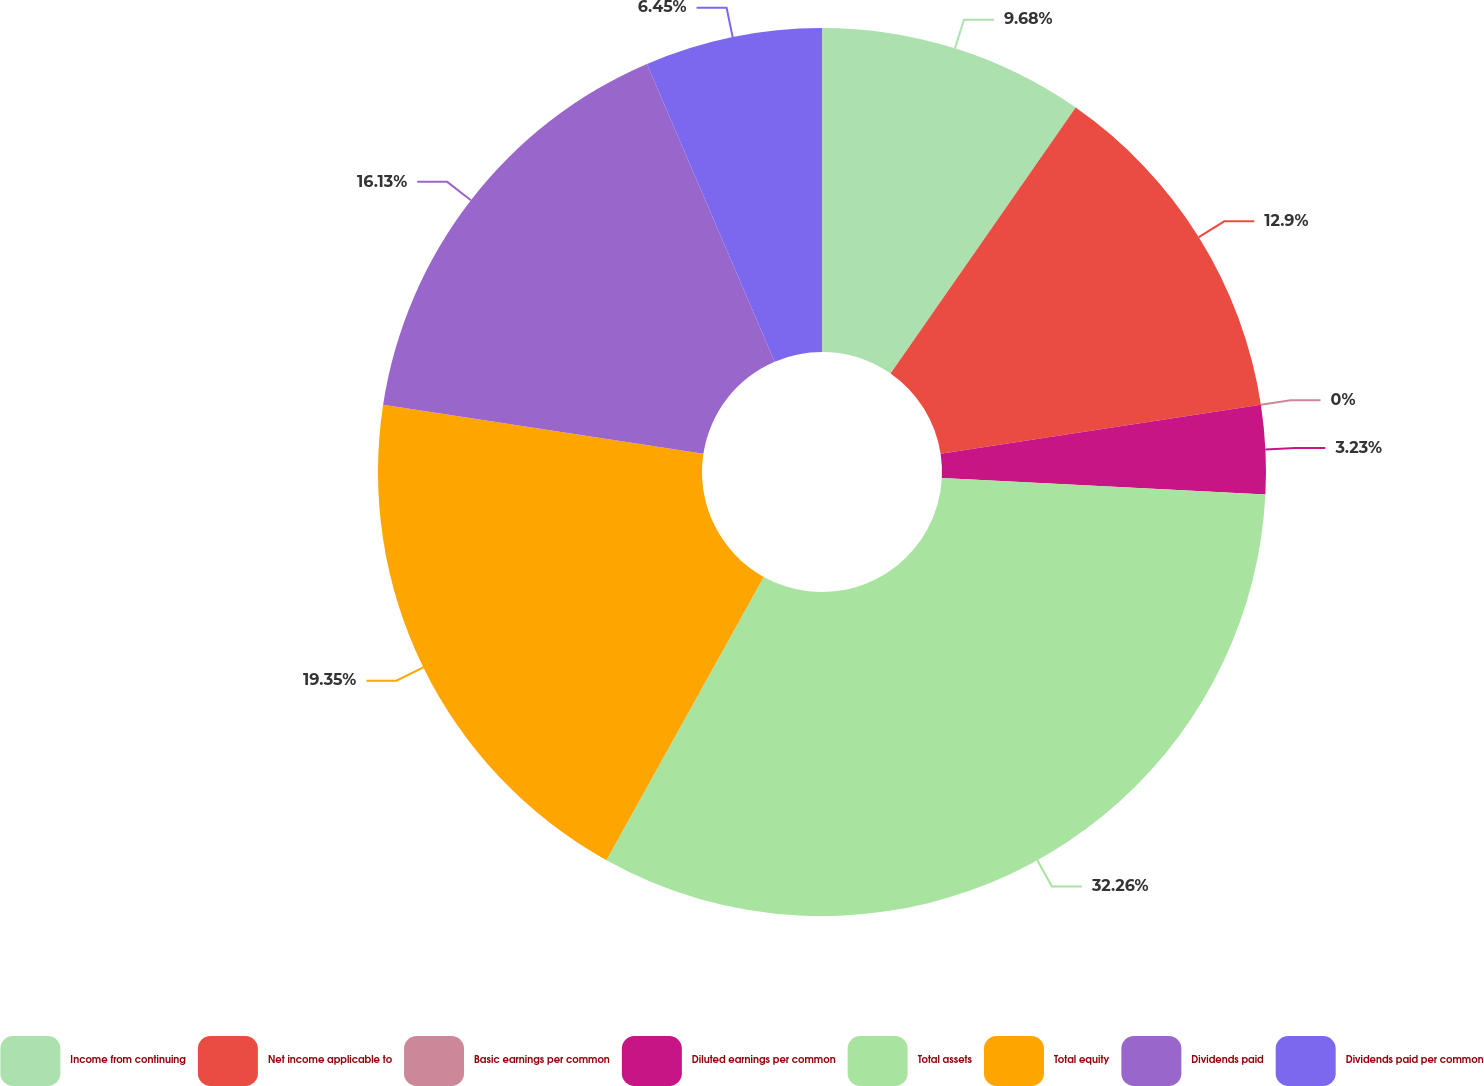Convert chart. <chart><loc_0><loc_0><loc_500><loc_500><pie_chart><fcel>Income from continuing<fcel>Net income applicable to<fcel>Basic earnings per common<fcel>Diluted earnings per common<fcel>Total assets<fcel>Total equity<fcel>Dividends paid<fcel>Dividends paid per common<nl><fcel>9.68%<fcel>12.9%<fcel>0.0%<fcel>3.23%<fcel>32.26%<fcel>19.35%<fcel>16.13%<fcel>6.45%<nl></chart> 